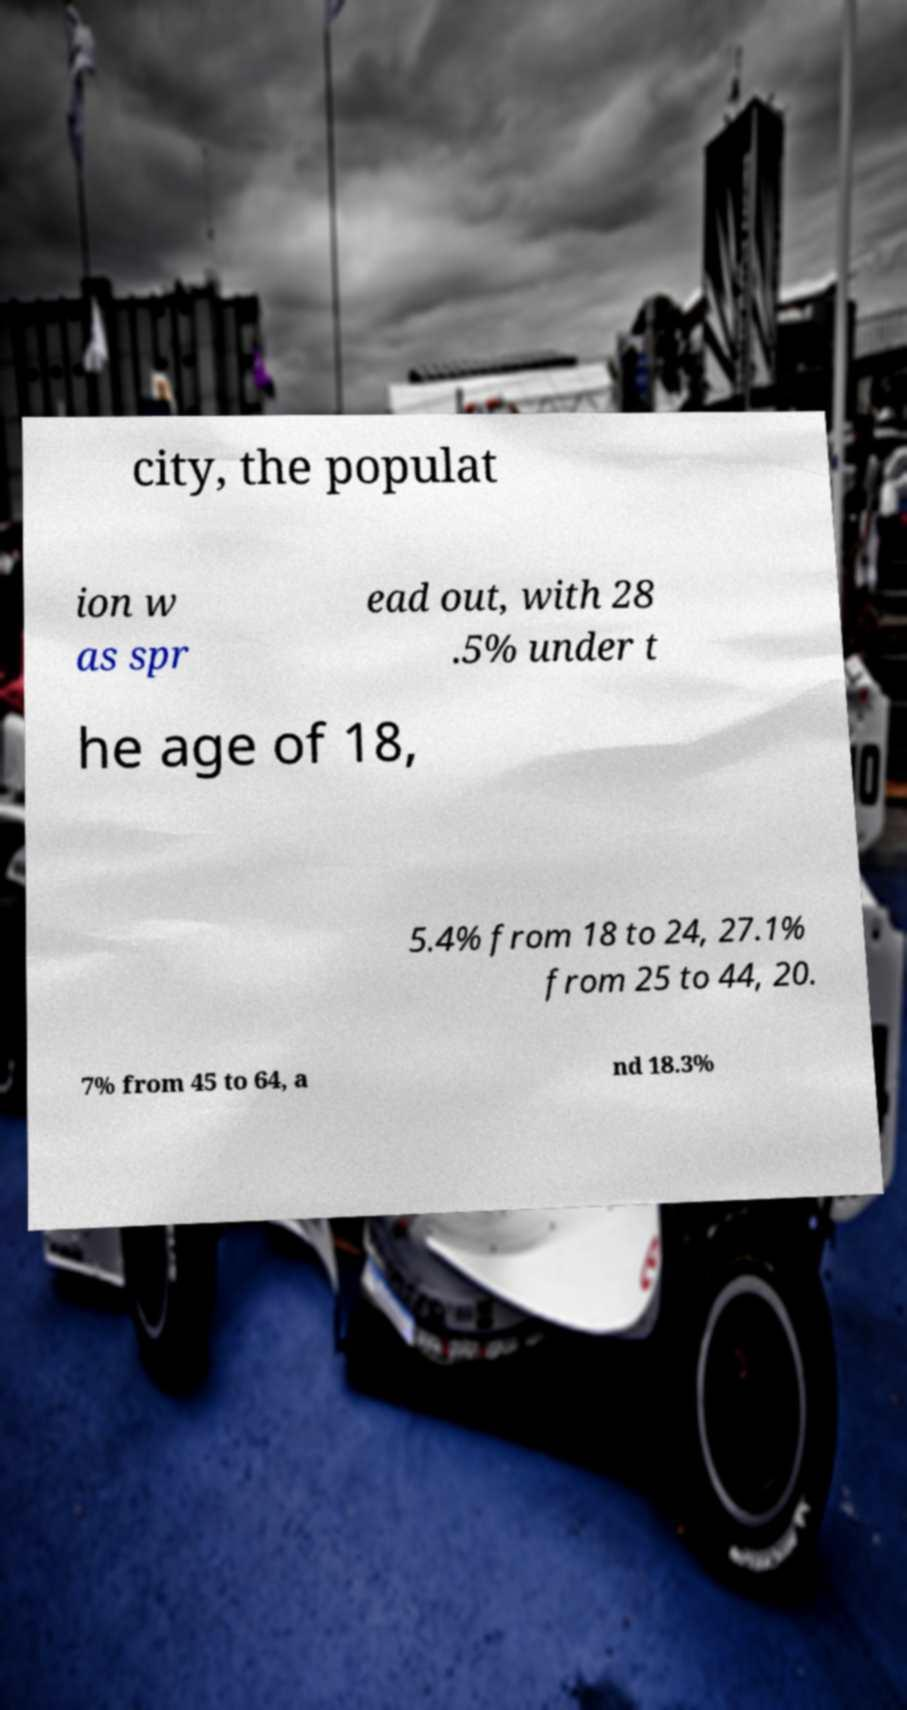There's text embedded in this image that I need extracted. Can you transcribe it verbatim? city, the populat ion w as spr ead out, with 28 .5% under t he age of 18, 5.4% from 18 to 24, 27.1% from 25 to 44, 20. 7% from 45 to 64, a nd 18.3% 